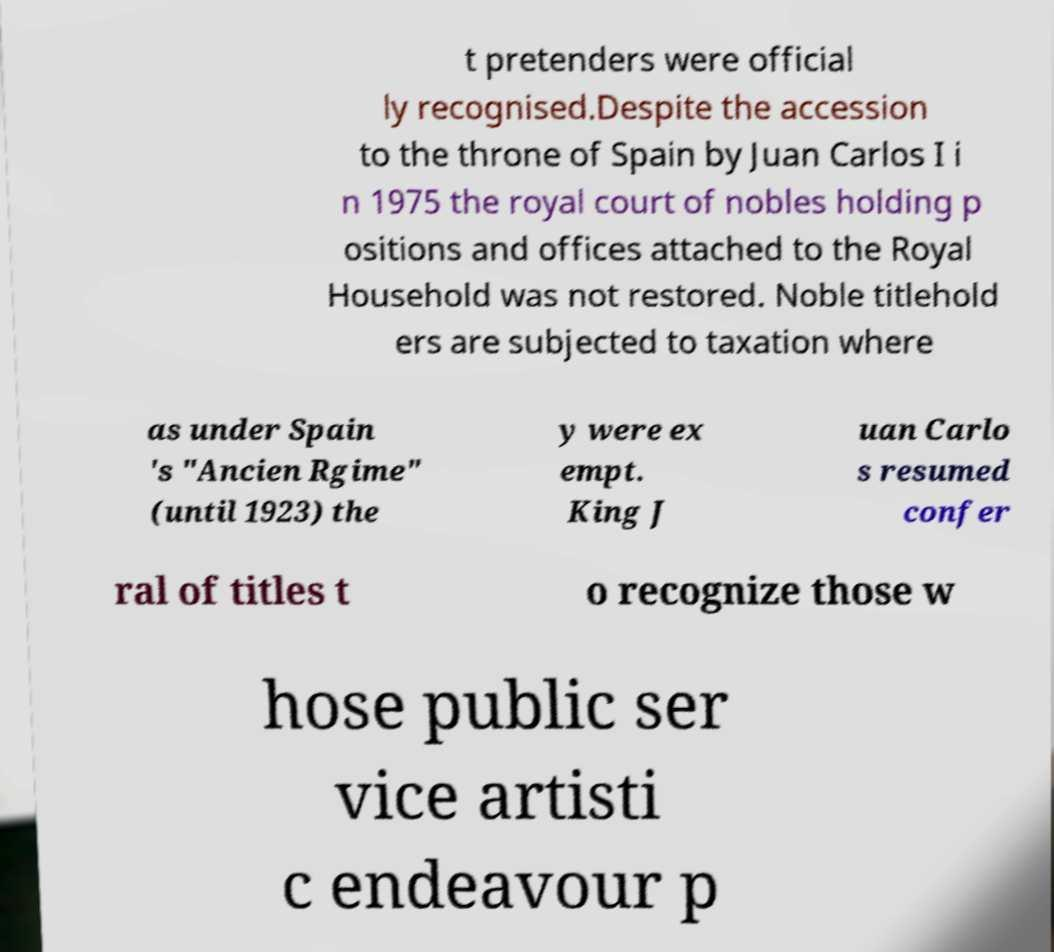Could you assist in decoding the text presented in this image and type it out clearly? t pretenders were official ly recognised.Despite the accession to the throne of Spain by Juan Carlos I i n 1975 the royal court of nobles holding p ositions and offices attached to the Royal Household was not restored. Noble titlehold ers are subjected to taxation where as under Spain 's "Ancien Rgime" (until 1923) the y were ex empt. King J uan Carlo s resumed confer ral of titles t o recognize those w hose public ser vice artisti c endeavour p 